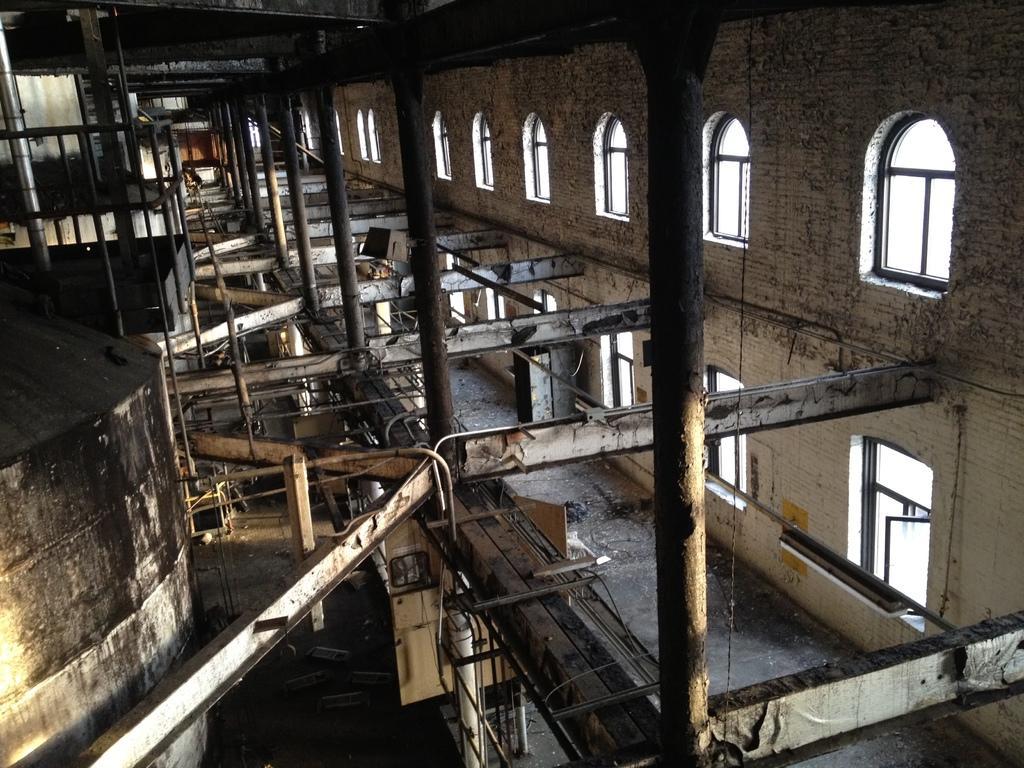In one or two sentences, can you explain what this image depicts? This is an inside view. Here I can see many pillars and metal objects on the floor. On the left side there is a wall and on the right side I can see many windows to the wall. 